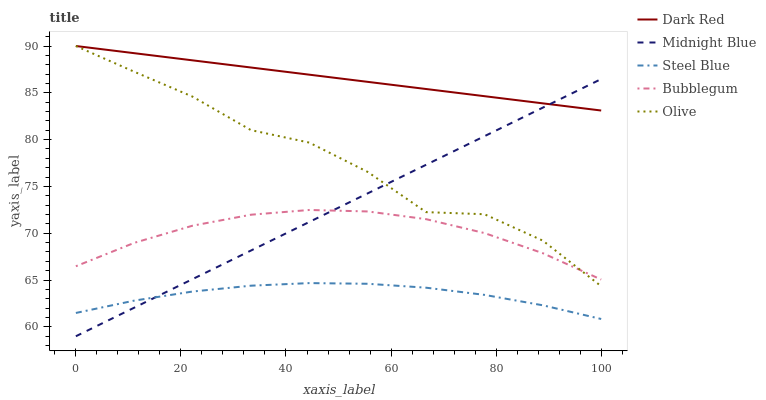Does Steel Blue have the minimum area under the curve?
Answer yes or no. Yes. Does Dark Red have the maximum area under the curve?
Answer yes or no. Yes. Does Midnight Blue have the minimum area under the curve?
Answer yes or no. No. Does Midnight Blue have the maximum area under the curve?
Answer yes or no. No. Is Midnight Blue the smoothest?
Answer yes or no. Yes. Is Olive the roughest?
Answer yes or no. Yes. Is Dark Red the smoothest?
Answer yes or no. No. Is Dark Red the roughest?
Answer yes or no. No. Does Midnight Blue have the lowest value?
Answer yes or no. Yes. Does Dark Red have the lowest value?
Answer yes or no. No. Does Dark Red have the highest value?
Answer yes or no. Yes. Does Midnight Blue have the highest value?
Answer yes or no. No. Is Steel Blue less than Dark Red?
Answer yes or no. Yes. Is Olive greater than Steel Blue?
Answer yes or no. Yes. Does Midnight Blue intersect Steel Blue?
Answer yes or no. Yes. Is Midnight Blue less than Steel Blue?
Answer yes or no. No. Is Midnight Blue greater than Steel Blue?
Answer yes or no. No. Does Steel Blue intersect Dark Red?
Answer yes or no. No. 